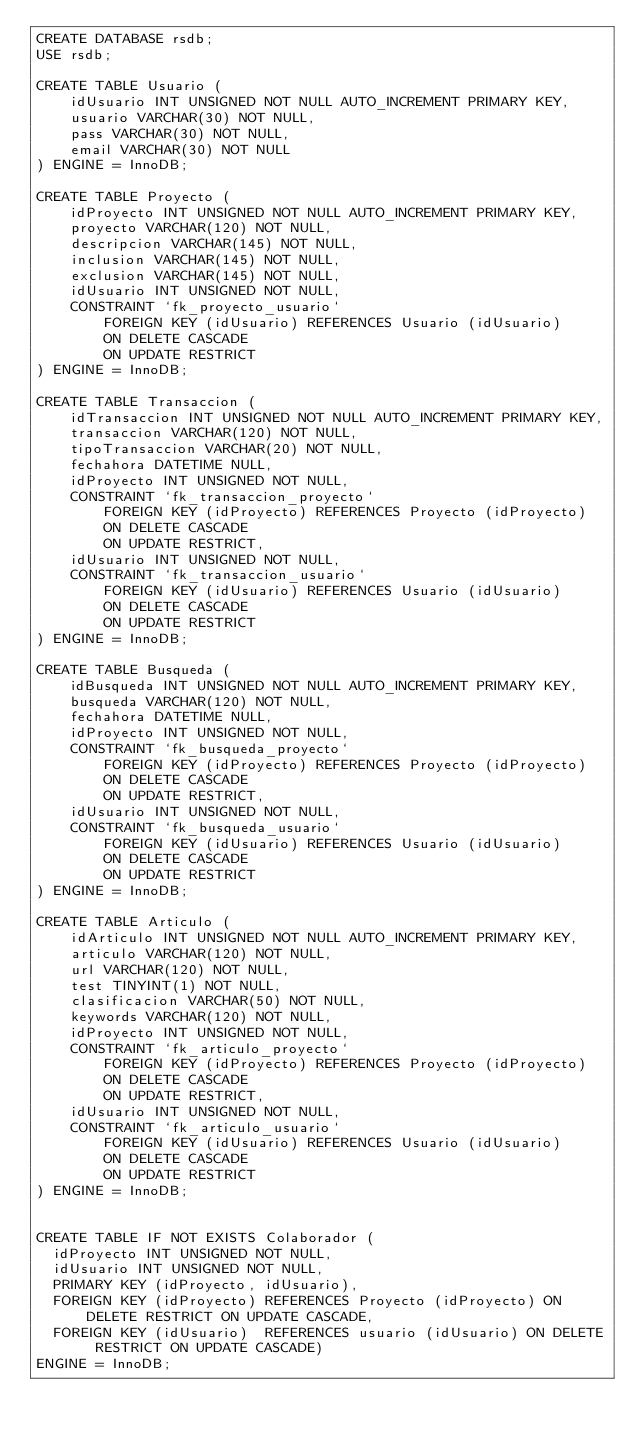<code> <loc_0><loc_0><loc_500><loc_500><_SQL_>CREATE DATABASE rsdb;
USE rsdb;

CREATE TABLE Usuario (
	idUsuario INT UNSIGNED NOT NULL AUTO_INCREMENT PRIMARY KEY,
	usuario VARCHAR(30) NOT NULL,
    pass VARCHAR(30) NOT NULL,
    email VARCHAR(30) NOT NULL
) ENGINE = InnoDB;

CREATE TABLE Proyecto (
	idProyecto INT UNSIGNED NOT NULL AUTO_INCREMENT PRIMARY KEY,
	proyecto VARCHAR(120) NOT NULL,
    descripcion VARCHAR(145) NOT NULL,
    inclusion VARCHAR(145) NOT NULL,
    exclusion VARCHAR(145) NOT NULL,
    idUsuario INT UNSIGNED NOT NULL,
    CONSTRAINT `fk_proyecto_usuario`
		FOREIGN KEY (idUsuario) REFERENCES Usuario (idUsuario)
		ON DELETE CASCADE
		ON UPDATE RESTRICT
) ENGINE = InnoDB;

CREATE TABLE Transaccion (
	idTransaccion INT UNSIGNED NOT NULL AUTO_INCREMENT PRIMARY KEY,
	transaccion VARCHAR(120) NOT NULL,
    tipoTransaccion VARCHAR(20) NOT NULL,
    fechahora DATETIME NULL,
    idProyecto INT UNSIGNED NOT NULL,
    CONSTRAINT `fk_transaccion_proyecto`
		FOREIGN KEY (idProyecto) REFERENCES Proyecto (idProyecto)
		ON DELETE CASCADE
		ON UPDATE RESTRICT,
    idUsuario INT UNSIGNED NOT NULL,
    CONSTRAINT `fk_transaccion_usuario`
		FOREIGN KEY (idUsuario) REFERENCES Usuario (idUsuario)
		ON DELETE CASCADE
		ON UPDATE RESTRICT    
) ENGINE = InnoDB;

CREATE TABLE Busqueda (
	idBusqueda INT UNSIGNED NOT NULL AUTO_INCREMENT PRIMARY KEY,
	busqueda VARCHAR(120) NOT NULL,
    fechahora DATETIME NULL,
    idProyecto INT UNSIGNED NOT NULL,
    CONSTRAINT `fk_busqueda_proyecto`
		FOREIGN KEY (idProyecto) REFERENCES Proyecto (idProyecto)
		ON DELETE CASCADE
		ON UPDATE RESTRICT,
    idUsuario INT UNSIGNED NOT NULL,
    CONSTRAINT `fk_busqueda_usuario`
		FOREIGN KEY (idUsuario) REFERENCES Usuario (idUsuario)
		ON DELETE CASCADE
		ON UPDATE RESTRICT    
) ENGINE = InnoDB;

CREATE TABLE Articulo (
	idArticulo INT UNSIGNED NOT NULL AUTO_INCREMENT PRIMARY KEY,
	articulo VARCHAR(120) NOT NULL,
    url VARCHAR(120) NOT NULL,
    test TINYINT(1) NOT NULL,
    clasificacion VARCHAR(50) NOT NULL,
    keywords VARCHAR(120) NOT NULL,
    idProyecto INT UNSIGNED NOT NULL,
    CONSTRAINT `fk_articulo_proyecto`
		FOREIGN KEY (idProyecto) REFERENCES Proyecto (idProyecto)
		ON DELETE CASCADE
		ON UPDATE RESTRICT,
    idUsuario INT UNSIGNED NOT NULL,
    CONSTRAINT `fk_articulo_usuario`
		FOREIGN KEY (idUsuario) REFERENCES Usuario (idUsuario)
		ON DELETE CASCADE
		ON UPDATE RESTRICT    
) ENGINE = InnoDB;


CREATE TABLE IF NOT EXISTS Colaborador (
  idProyecto INT UNSIGNED NOT NULL,
  idUsuario INT UNSIGNED NOT NULL,
  PRIMARY KEY (idProyecto, idUsuario),
  FOREIGN KEY (idProyecto) REFERENCES Proyecto (idProyecto) ON DELETE RESTRICT ON UPDATE CASCADE,
  FOREIGN KEY (idUsuario)  REFERENCES usuario (idUsuario) ON DELETE RESTRICT ON UPDATE CASCADE)
ENGINE = InnoDB;
</code> 